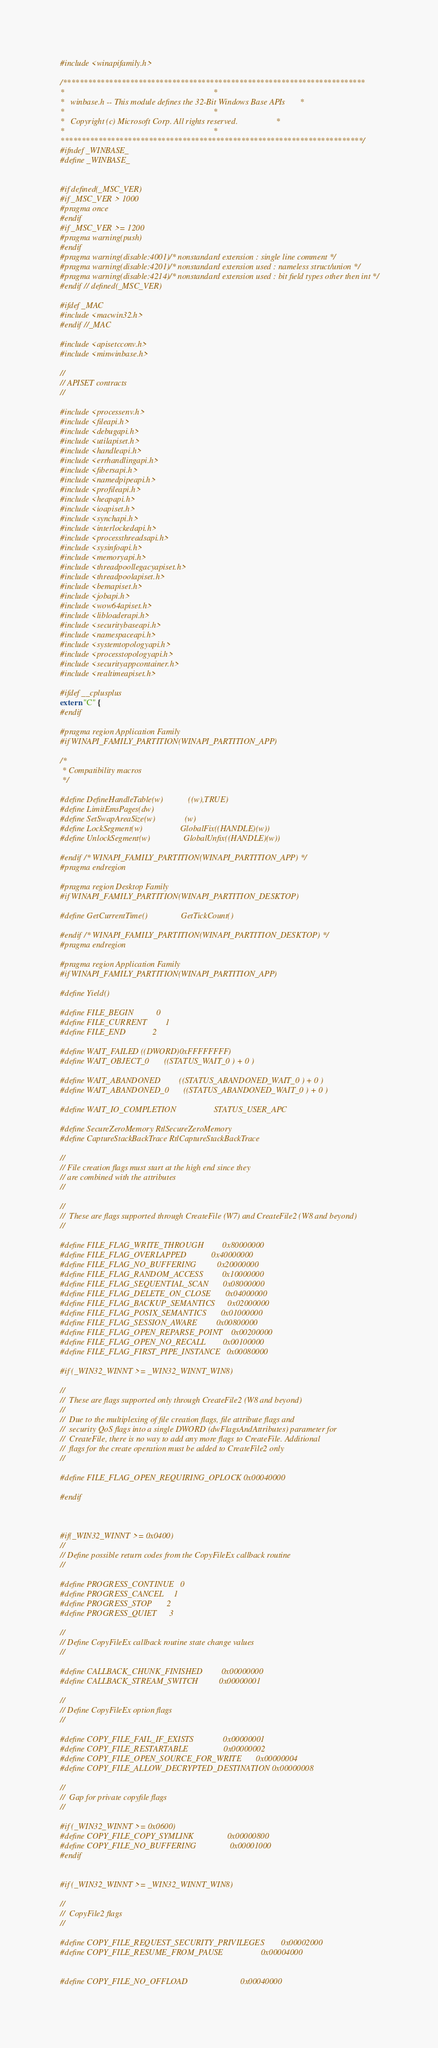<code> <loc_0><loc_0><loc_500><loc_500><_C_>#include <winapifamily.h>

/************************************************************************
*                                                                       *
*   winbase.h -- This module defines the 32-Bit Windows Base APIs       *
*                                                                       *
*   Copyright (c) Microsoft Corp. All rights reserved.                  *
*                                                                       *
************************************************************************/
#ifndef _WINBASE_
#define _WINBASE_


#if defined(_MSC_VER)
#if _MSC_VER > 1000
#pragma once
#endif
#if _MSC_VER >= 1200
#pragma warning(push)
#endif
#pragma warning(disable:4001) /* nonstandard extension : single line comment */
#pragma warning(disable:4201) /* nonstandard extension used : nameless struct/union */
#pragma warning(disable:4214) /* nonstandard extension used : bit field types other then int */
#endif // defined(_MSC_VER)

#ifdef _MAC
#include <macwin32.h>
#endif //_MAC

#include <apisetcconv.h>
#include <minwinbase.h>

//
// APISET contracts
//

#include <processenv.h>
#include <fileapi.h>
#include <debugapi.h>
#include <utilapiset.h>
#include <handleapi.h>
#include <errhandlingapi.h>
#include <fibersapi.h>
#include <namedpipeapi.h>
#include <profileapi.h>
#include <heapapi.h>
#include <ioapiset.h>
#include <synchapi.h>
#include <interlockedapi.h>
#include <processthreadsapi.h>
#include <sysinfoapi.h>
#include <memoryapi.h>
#include <threadpoollegacyapiset.h>
#include <threadpoolapiset.h>
#include <bemapiset.h>
#include <jobapi.h>
#include <wow64apiset.h>
#include <libloaderapi.h>
#include <securitybaseapi.h>
#include <namespaceapi.h>
#include <systemtopologyapi.h>
#include <processtopologyapi.h>
#include <securityappcontainer.h>
#include <realtimeapiset.h>

#ifdef __cplusplus
extern "C" {
#endif

#pragma region Application Family
#if WINAPI_FAMILY_PARTITION(WINAPI_PARTITION_APP)

/*
 * Compatibility macros
 */

#define DefineHandleTable(w)            ((w),TRUE)
#define LimitEmsPages(dw)
#define SetSwapAreaSize(w)              (w)
#define LockSegment(w)                  GlobalFix((HANDLE)(w))
#define UnlockSegment(w)                GlobalUnfix((HANDLE)(w))

#endif /* WINAPI_FAMILY_PARTITION(WINAPI_PARTITION_APP) */
#pragma endregion

#pragma region Desktop Family
#if WINAPI_FAMILY_PARTITION(WINAPI_PARTITION_DESKTOP)

#define GetCurrentTime()                GetTickCount()

#endif /* WINAPI_FAMILY_PARTITION(WINAPI_PARTITION_DESKTOP) */
#pragma endregion

#pragma region Application Family
#if WINAPI_FAMILY_PARTITION(WINAPI_PARTITION_APP)

#define Yield()

#define FILE_BEGIN           0
#define FILE_CURRENT         1
#define FILE_END             2

#define WAIT_FAILED ((DWORD)0xFFFFFFFF)
#define WAIT_OBJECT_0       ((STATUS_WAIT_0 ) + 0 )

#define WAIT_ABANDONED         ((STATUS_ABANDONED_WAIT_0 ) + 0 )
#define WAIT_ABANDONED_0       ((STATUS_ABANDONED_WAIT_0 ) + 0 )

#define WAIT_IO_COMPLETION                  STATUS_USER_APC

#define SecureZeroMemory RtlSecureZeroMemory
#define CaptureStackBackTrace RtlCaptureStackBackTrace

//
// File creation flags must start at the high end since they
// are combined with the attributes
//

//
//  These are flags supported through CreateFile (W7) and CreateFile2 (W8 and beyond)
//

#define FILE_FLAG_WRITE_THROUGH         0x80000000
#define FILE_FLAG_OVERLAPPED            0x40000000
#define FILE_FLAG_NO_BUFFERING          0x20000000
#define FILE_FLAG_RANDOM_ACCESS         0x10000000
#define FILE_FLAG_SEQUENTIAL_SCAN       0x08000000
#define FILE_FLAG_DELETE_ON_CLOSE       0x04000000
#define FILE_FLAG_BACKUP_SEMANTICS      0x02000000
#define FILE_FLAG_POSIX_SEMANTICS       0x01000000
#define FILE_FLAG_SESSION_AWARE         0x00800000
#define FILE_FLAG_OPEN_REPARSE_POINT    0x00200000
#define FILE_FLAG_OPEN_NO_RECALL        0x00100000
#define FILE_FLAG_FIRST_PIPE_INSTANCE   0x00080000

#if (_WIN32_WINNT >= _WIN32_WINNT_WIN8)

//
//  These are flags supported only through CreateFile2 (W8 and beyond)
//
//  Due to the multiplexing of file creation flags, file attribute flags and
//  security QoS flags into a single DWORD (dwFlagsAndAttributes) parameter for
//  CreateFile, there is no way to add any more flags to CreateFile. Additional
//  flags for the create operation must be added to CreateFile2 only
//

#define FILE_FLAG_OPEN_REQUIRING_OPLOCK 0x00040000

#endif



#if(_WIN32_WINNT >= 0x0400)
//
// Define possible return codes from the CopyFileEx callback routine
//

#define PROGRESS_CONTINUE   0
#define PROGRESS_CANCEL     1
#define PROGRESS_STOP       2
#define PROGRESS_QUIET      3

//
// Define CopyFileEx callback routine state change values
//

#define CALLBACK_CHUNK_FINISHED         0x00000000
#define CALLBACK_STREAM_SWITCH          0x00000001

//
// Define CopyFileEx option flags
//

#define COPY_FILE_FAIL_IF_EXISTS              0x00000001
#define COPY_FILE_RESTARTABLE                 0x00000002
#define COPY_FILE_OPEN_SOURCE_FOR_WRITE       0x00000004
#define COPY_FILE_ALLOW_DECRYPTED_DESTINATION 0x00000008

//
//  Gap for private copyfile flags
//

#if (_WIN32_WINNT >= 0x0600)
#define COPY_FILE_COPY_SYMLINK                0x00000800
#define COPY_FILE_NO_BUFFERING                0x00001000
#endif


#if (_WIN32_WINNT >= _WIN32_WINNT_WIN8)

//
//  CopyFile2 flags
//

#define COPY_FILE_REQUEST_SECURITY_PRIVILEGES        0x00002000
#define COPY_FILE_RESUME_FROM_PAUSE                  0x00004000


#define COPY_FILE_NO_OFFLOAD                         0x00040000
</code> 